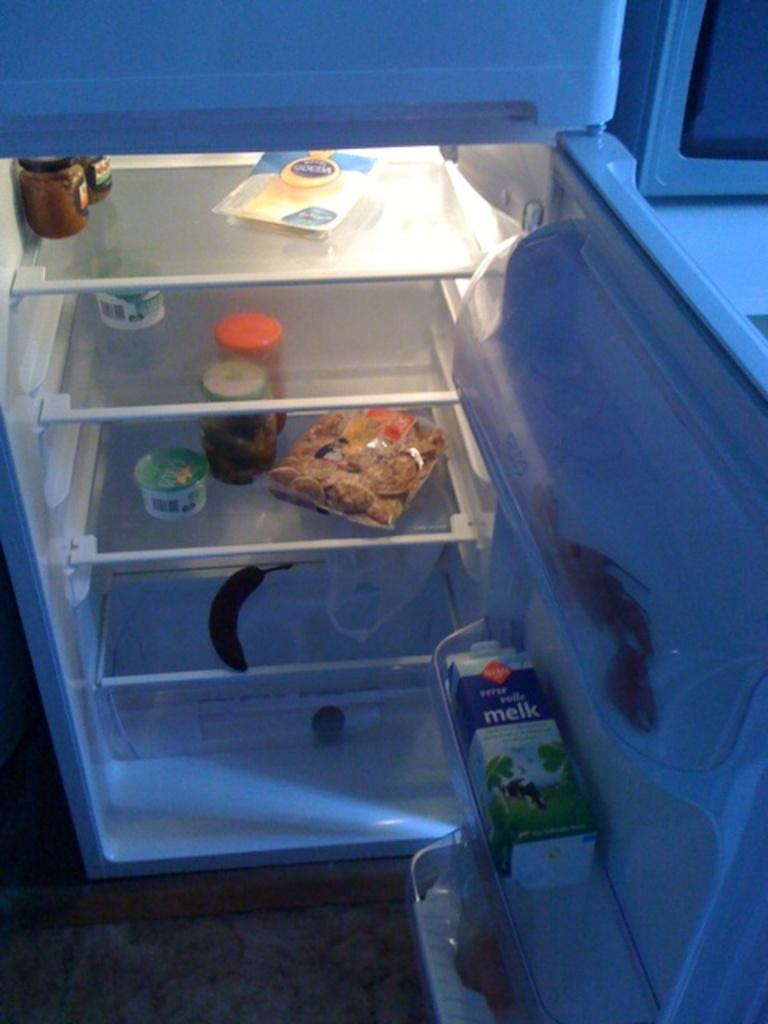<image>
Share a concise interpretation of the image provided. A refrigerator with Melk sitting on the door. 